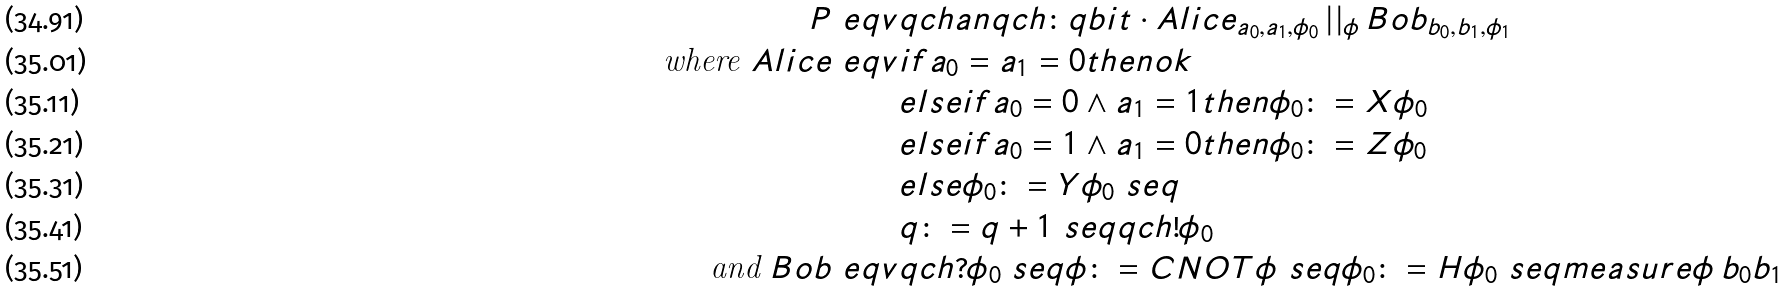<formula> <loc_0><loc_0><loc_500><loc_500>P \ e q v & q c h a n q c h \colon q b i t \cdot A l i c e _ { a _ { 0 } , a _ { 1 } , \phi _ { 0 } } \, | | _ { \phi } \, B o b _ { b _ { 0 } , b _ { 1 } , \phi _ { 1 } } \\ \text {where } A l i c e \ e q v & i f a _ { 0 } = a _ { 1 } = 0 t h e n o k \\ & e l s e i f a _ { 0 } = 0 \land a _ { 1 } = 1 t h e n \phi _ { 0 } \colon = X \phi _ { 0 } \\ & e l s e i f a _ { 0 } = 1 \land a _ { 1 } = 0 t h e n \phi _ { 0 } \colon = Z \phi _ { 0 } \\ & e l s e \phi _ { 0 } \colon = Y \phi _ { 0 } \ s e q \\ & q \colon = q + 1 \ s e q q c h ! \phi _ { 0 } \\ \text {and } B o b \ e q v & q c h ? \phi _ { 0 } \ s e q \phi \colon = C N O T \phi \ s e q \phi _ { 0 } \colon = H \phi _ { 0 } \ s e q m e a s u r e \phi \, b _ { 0 } b _ { 1 }</formula> 